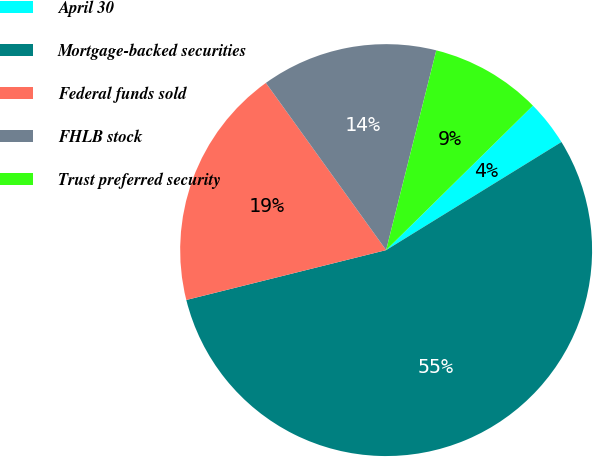Convert chart. <chart><loc_0><loc_0><loc_500><loc_500><pie_chart><fcel>April 30<fcel>Mortgage-backed securities<fcel>Federal funds sold<fcel>FHLB stock<fcel>Trust preferred security<nl><fcel>3.58%<fcel>54.9%<fcel>18.97%<fcel>13.84%<fcel>8.71%<nl></chart> 